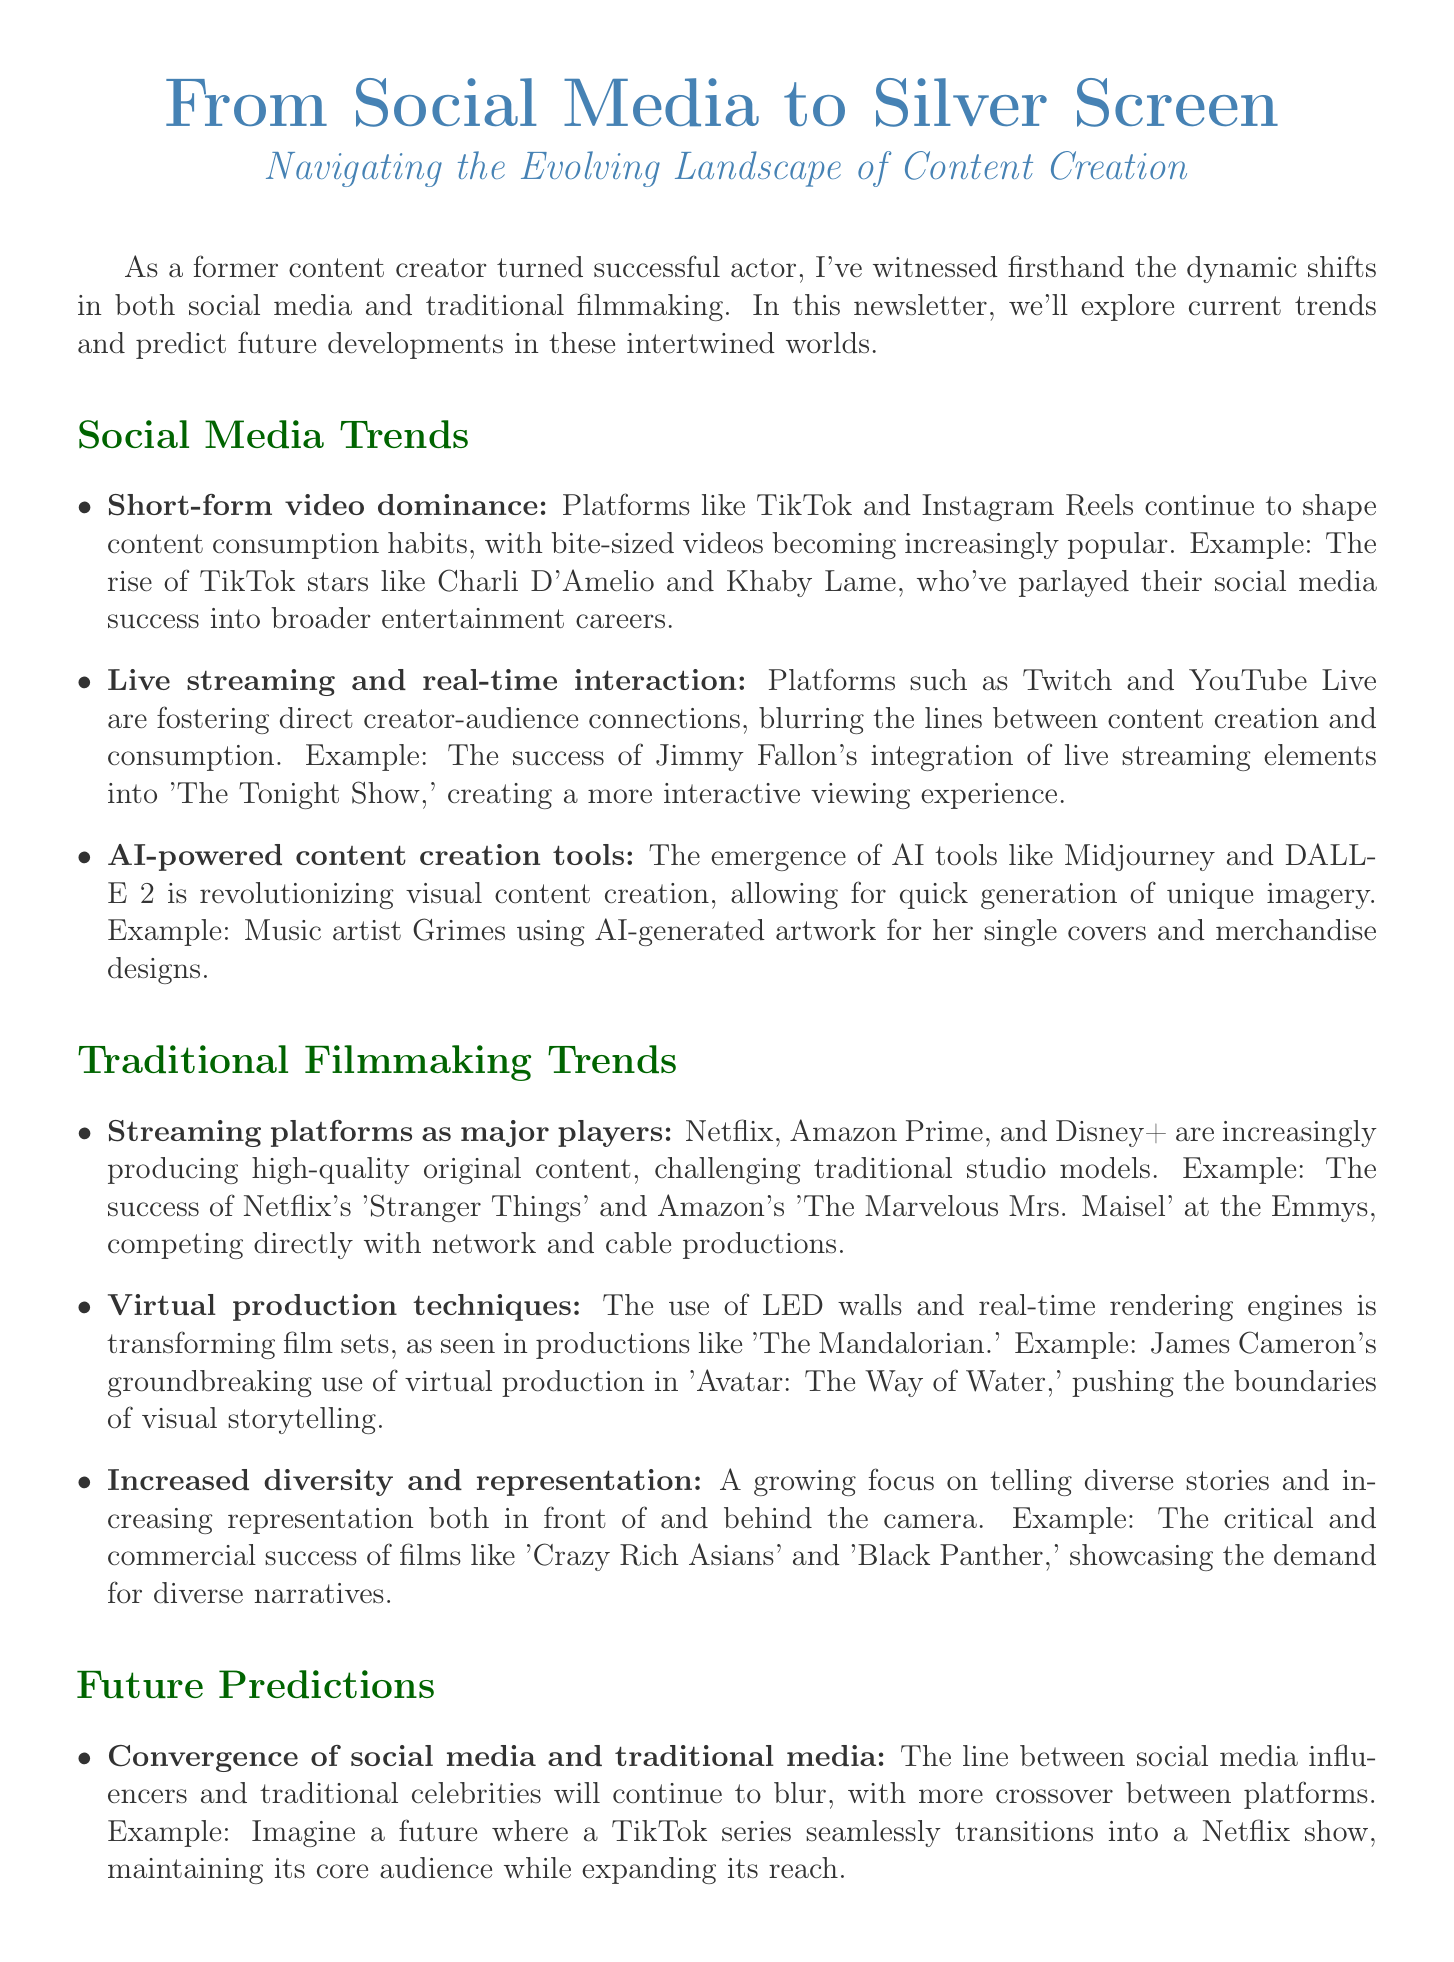What is the title of the newsletter? The title of the newsletter is given at the beginning of the document, which is "From Social Media to Silver Screen: Navigating the Evolving Landscape of Content Creation."
Answer: From Social Media to Silver Screen: Navigating the Evolving Landscape of Content Creation What trend highlights the popularity of short videos? The segment detailing social media trends includes a point about short-form video dominance, mentioning specific platforms influencing this habit.
Answer: Short-form video dominance What example is given for AI-powered content creation tools? The document provides an example illustrating the use of AI-generated artwork in the context of music, showcasing a specific artist and her work.
Answer: Grimes Which streaming platform is noted for producing "Stranger Things"? The document references popular content produced by streaming services and highlights "Stranger Things" as an example attributed to a specific platform.
Answer: Netflix What future prediction involves immersive storytelling experiences? The future predictions section discusses advancements in technology that will enhance storytelling, particularly through a specific type of media platform.
Answer: Virtual and augmented reality content What skill from content creation has proven invaluable in acting? The personal insight section shares reflections on skills developed from content creation and their importance in acting, focusing on a specific ability.
Answer: Adaptability What is a key theme in traditional filmmaking trends? The newsletter discusses various themes, and one specific area of focus is on representation and storytelling diversity in filmmaking.
Answer: Increased diversity and representation What is the expected trend between social media and traditional media? The document addresses predictions about the blending of two entertainment realms, indicating a specific trend that encompasses both worlds.
Answer: Convergence of social media and traditional media 